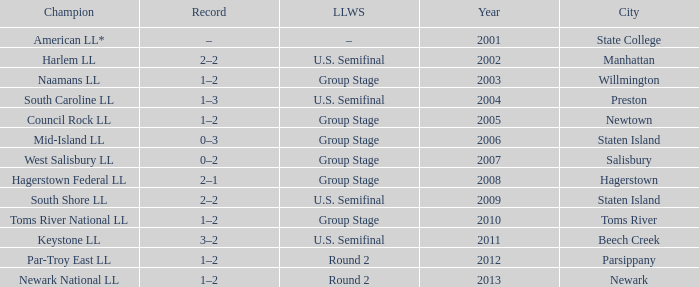Which Little League World Series took place in Parsippany? Round 2. 